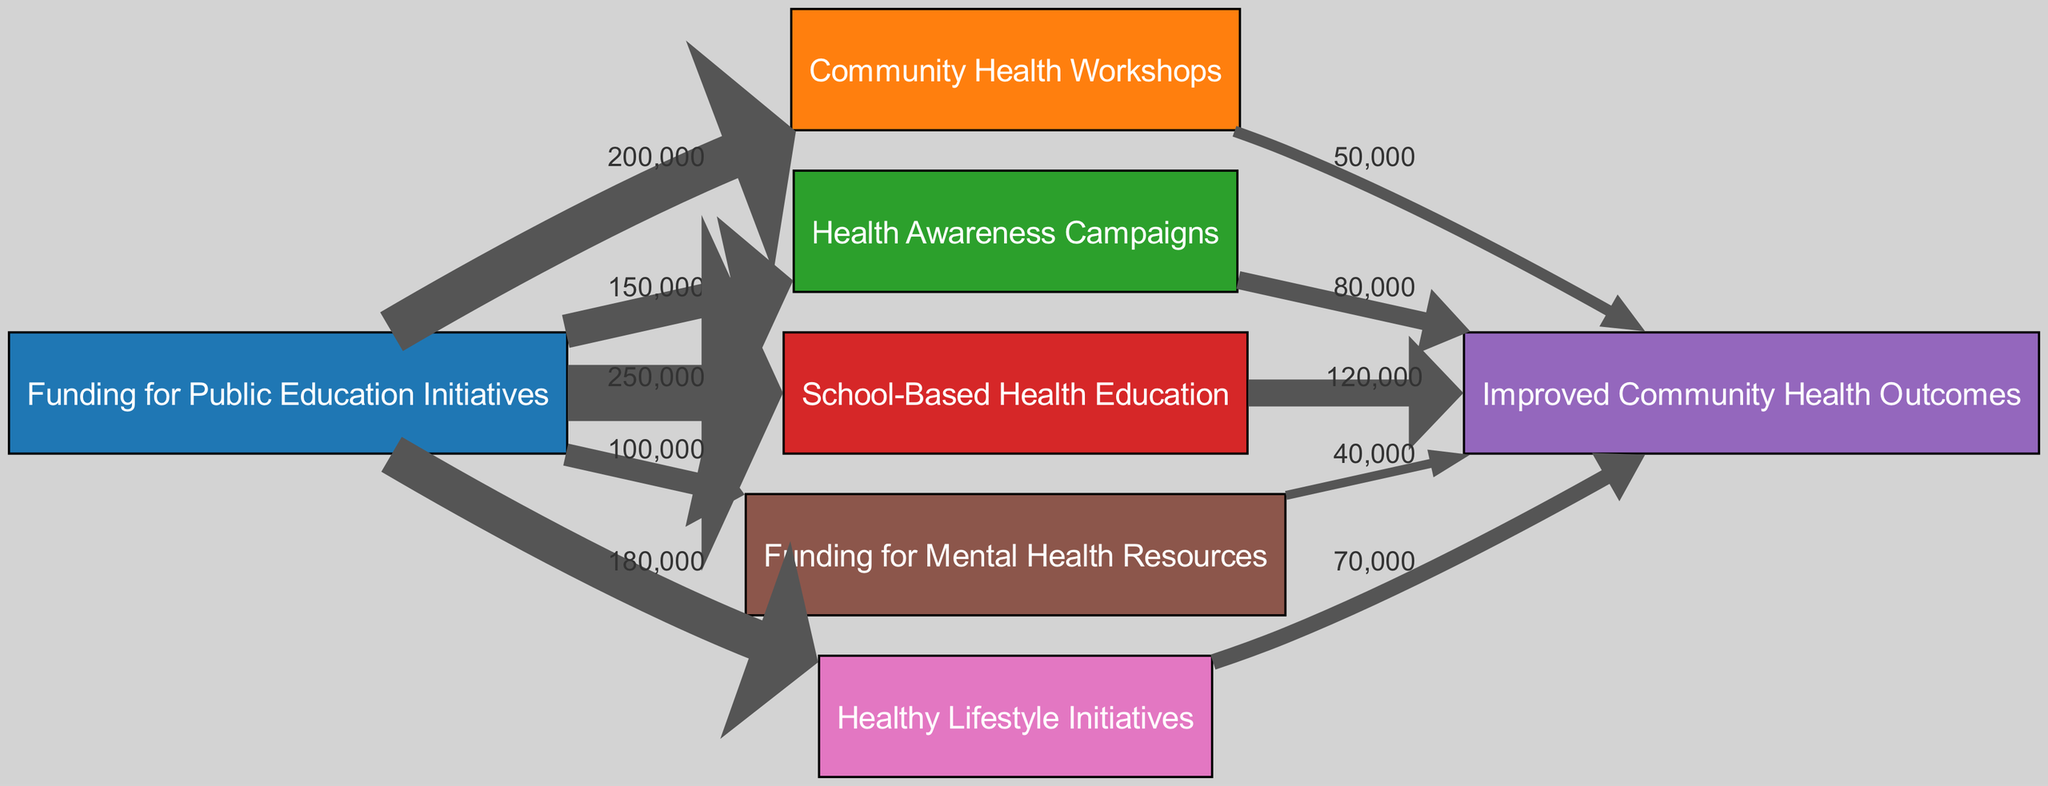What is the total funding allocated to School Programs? The diagram shows that the link from "Funding for Education" to "School Programs" has a value of 250000, indicating this is the total funding allocated.
Answer: 250000 How many nodes are there in the diagram? The diagram includes a total of 7 distinct nodes representing various aspects of public education initiatives and health outcomes.
Answer: 7 Which initiative received the least funding? By examining the flows from "Funding for Education," the link to "Mental Health Resources" has the lowest value of 100000, indicating this initiative received the least funding.
Answer: Mental Health Resources What is the total funding allocated to Community Workshops? The value of the link from "Funding for Education" to "Community Workshops" is 200000, which represents the total funding allocated to this initiative.
Answer: 200000 Which initiative has the highest impact on Public Health Outcomes? The link to "Public Health Outcomes" from "School Programs" has the highest value of 120000, indicating that this initiative has the highest impact on community health.
Answer: School Programs What can you conclude about the relationship between Awareness Campaigns and Public Health Outcomes? The value of the link from "Awareness Campaigns" to "Public Health Outcomes" is 80000, indicating a significant impact, but lower than that of "School Programs."
Answer: Impact indicated by 80000 How much funding directs to Healthy Lifestyle Initiatives? The funding directed to "Healthy Lifestyle Initiatives" from "Funding for Education" totals 180000, indicating the available budget.
Answer: 180000 How does the funding for mental health resources compare to community workshops? The funding for "Mental Health Resources" is 100000 while for "Community Workshops" it is 200000; community workshops received 100000 more.
Answer: 100000 more What percentage of the total funding goes to Awareness Campaigns compared to the total funding? The total funding from "Funding for Education" is 1,000,000. Awareness Campaigns received 150000, which is 15% of the total.
Answer: 15% 